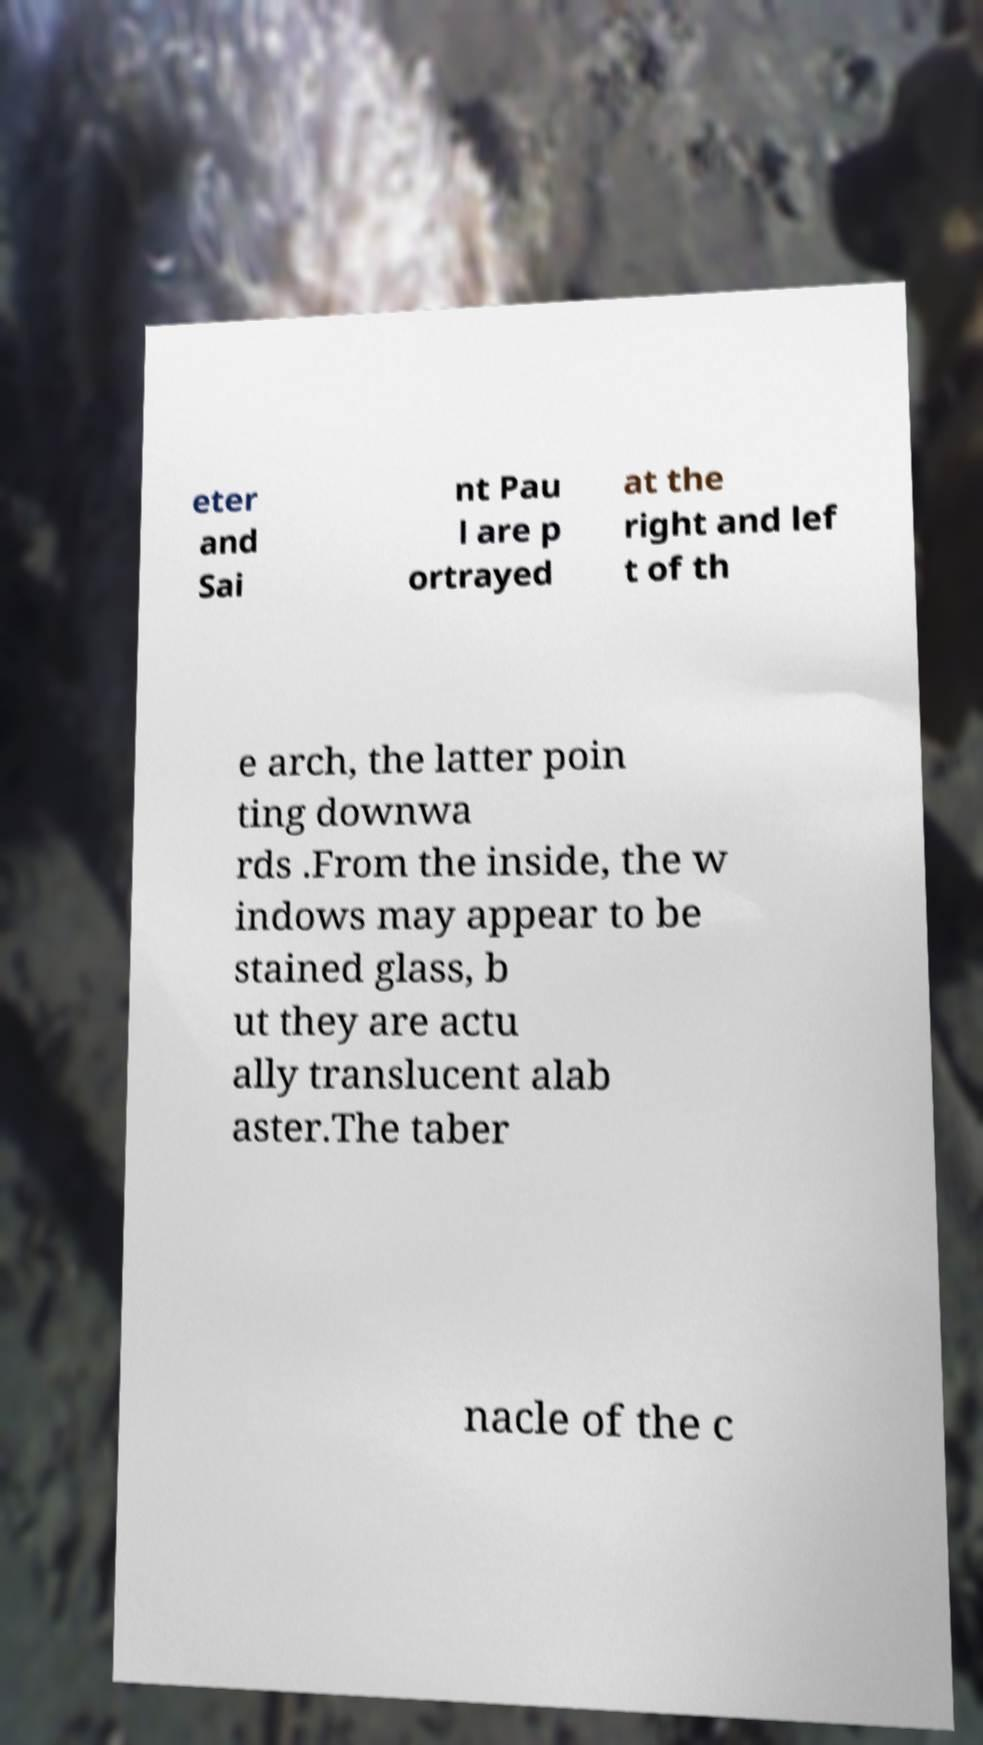For documentation purposes, I need the text within this image transcribed. Could you provide that? eter and Sai nt Pau l are p ortrayed at the right and lef t of th e arch, the latter poin ting downwa rds .From the inside, the w indows may appear to be stained glass, b ut they are actu ally translucent alab aster.The taber nacle of the c 